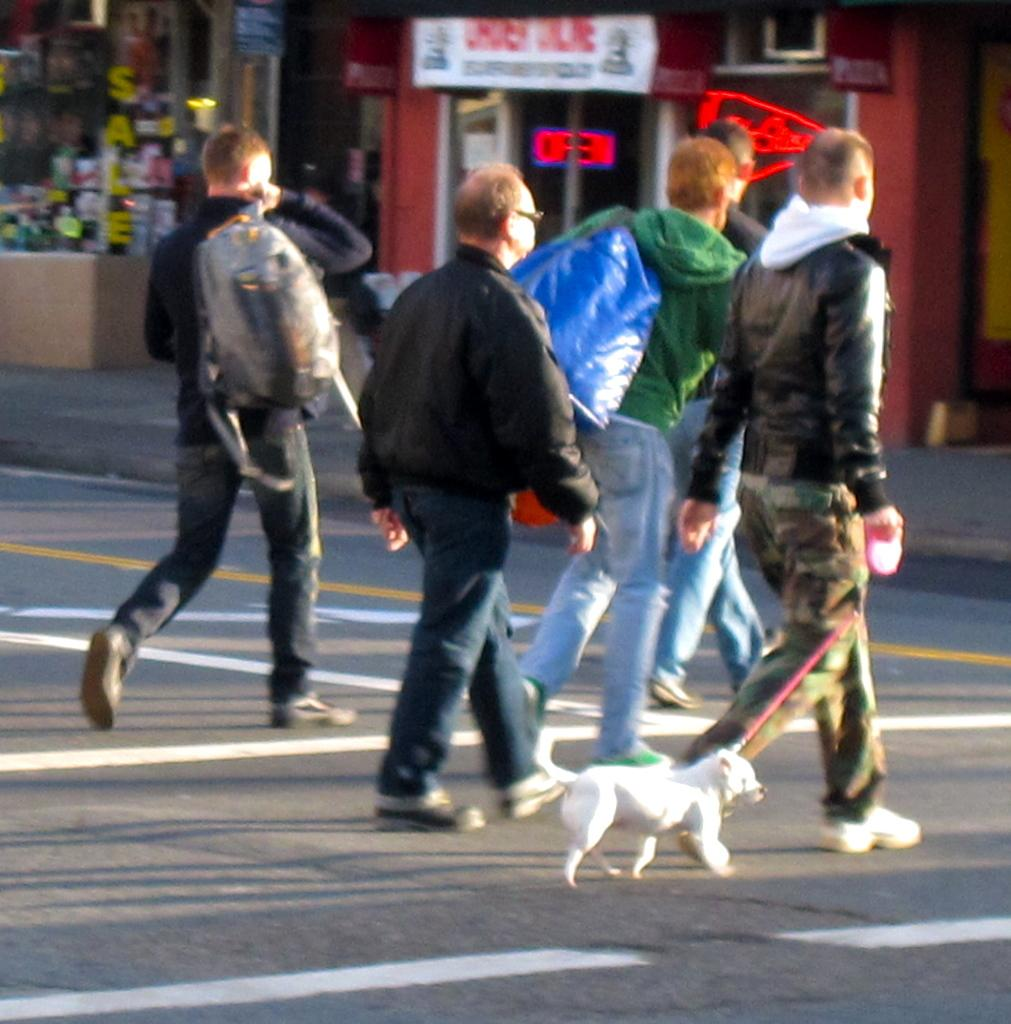Who or what can be seen in the image? There are people and a dog in the image. What are the people and dog doing in the image? The people and dog are crossing the road. What can be seen in the background of the image? There are stores and boards in the background of the image. What type of wren can be seen perched on the arm of one of the people in the image? There is no wren present in the image, nor is there any mention of an arm. 